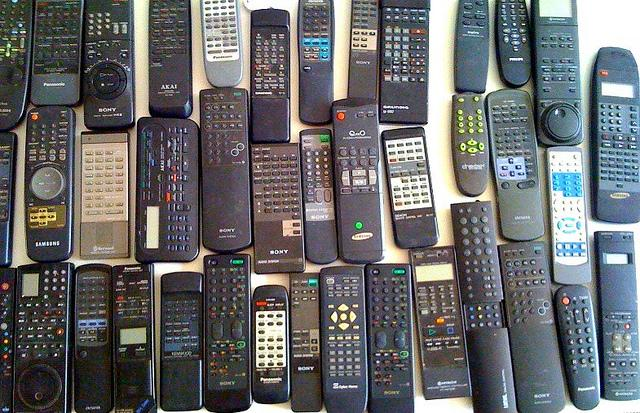Most of these items are probably used on what? Please explain your reasoning. televisions. The items are for tvs. 